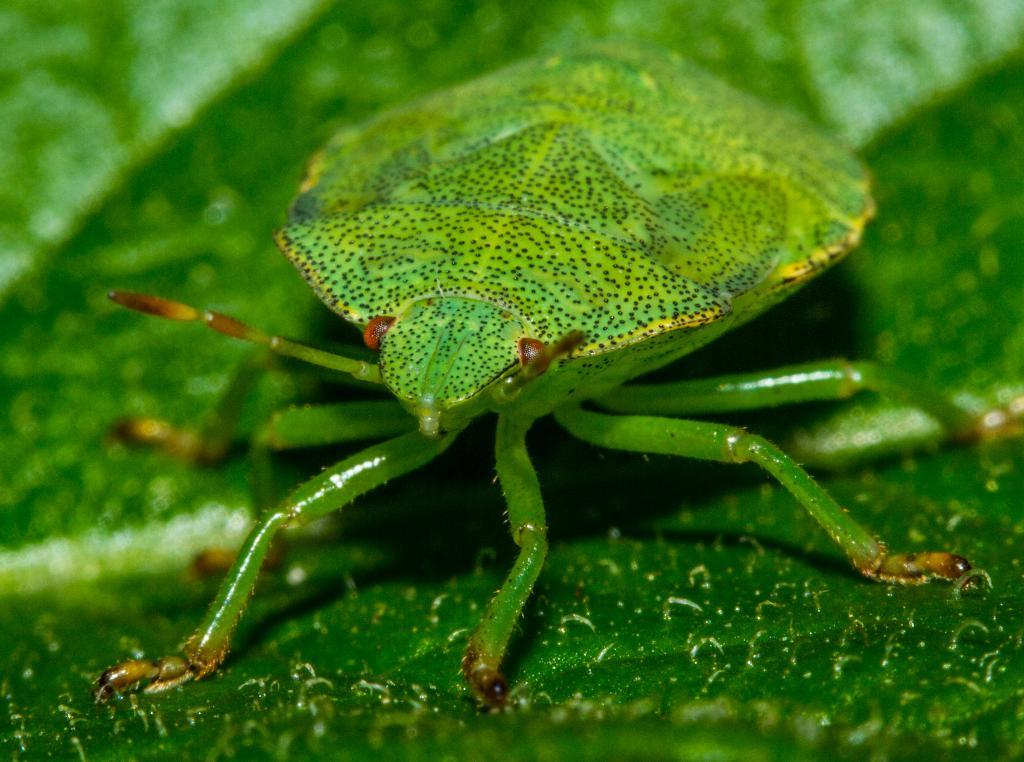What is present on the leaf in the image? There is an insect in the image. What is the insect's location on the leaf? The insect is on a leaf in the image. What color is the insect? The insect is green in color. What type of horn can be seen on the notebook in the image? There is no horn or notebook present in the image; it features an insect on a leaf. 